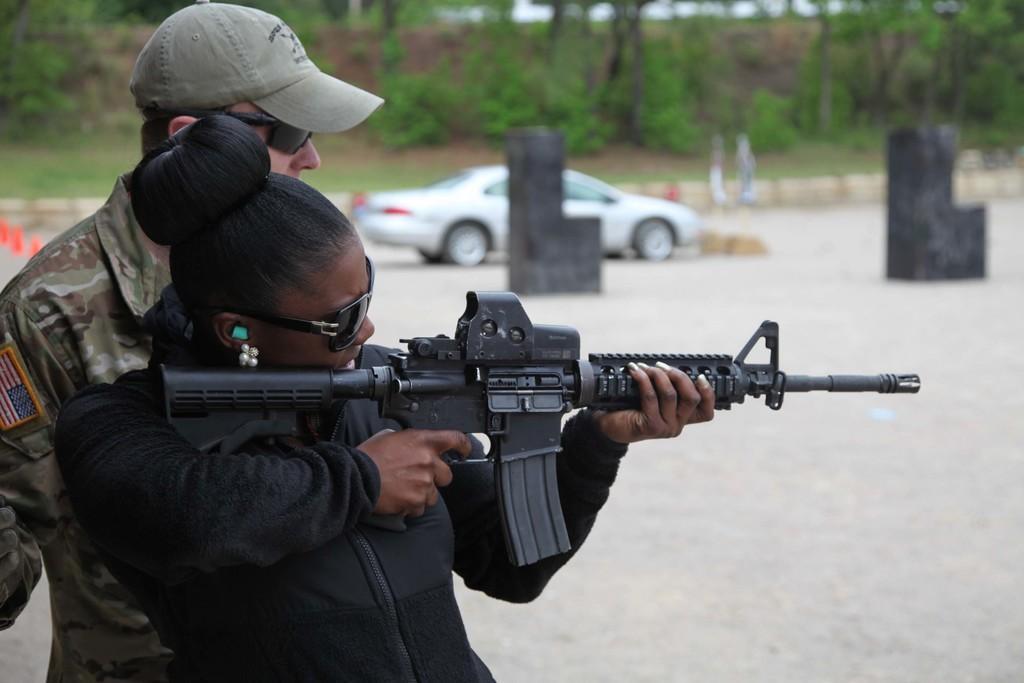Can you describe this image briefly? In this image there is a woman holding a gun in her hand, in the background there is a man standing and there is a car, trees and it is blurred. 